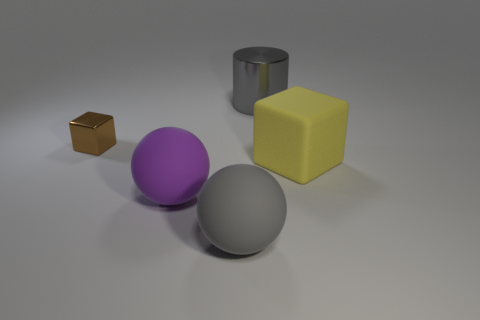Add 4 large gray spheres. How many objects exist? 9 Subtract all balls. How many objects are left? 3 Subtract 0 yellow cylinders. How many objects are left? 5 Subtract all gray cylinders. Subtract all big gray metallic objects. How many objects are left? 3 Add 1 large metallic things. How many large metallic things are left? 2 Add 2 small yellow shiny balls. How many small yellow shiny balls exist? 2 